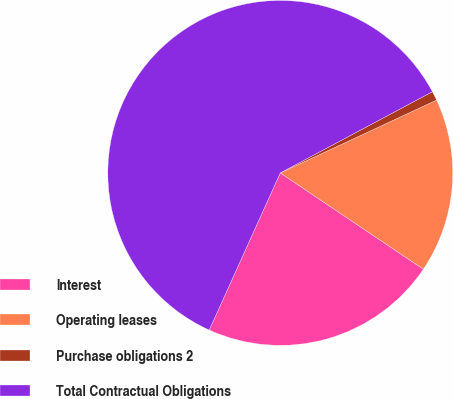Convert chart. <chart><loc_0><loc_0><loc_500><loc_500><pie_chart><fcel>Interest<fcel>Operating leases<fcel>Purchase obligations 2<fcel>Total Contractual Obligations<nl><fcel>22.33%<fcel>16.37%<fcel>0.86%<fcel>60.44%<nl></chart> 